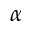Convert formula to latex. <formula><loc_0><loc_0><loc_500><loc_500>\alpha</formula> 